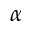Convert formula to latex. <formula><loc_0><loc_0><loc_500><loc_500>\alpha</formula> 